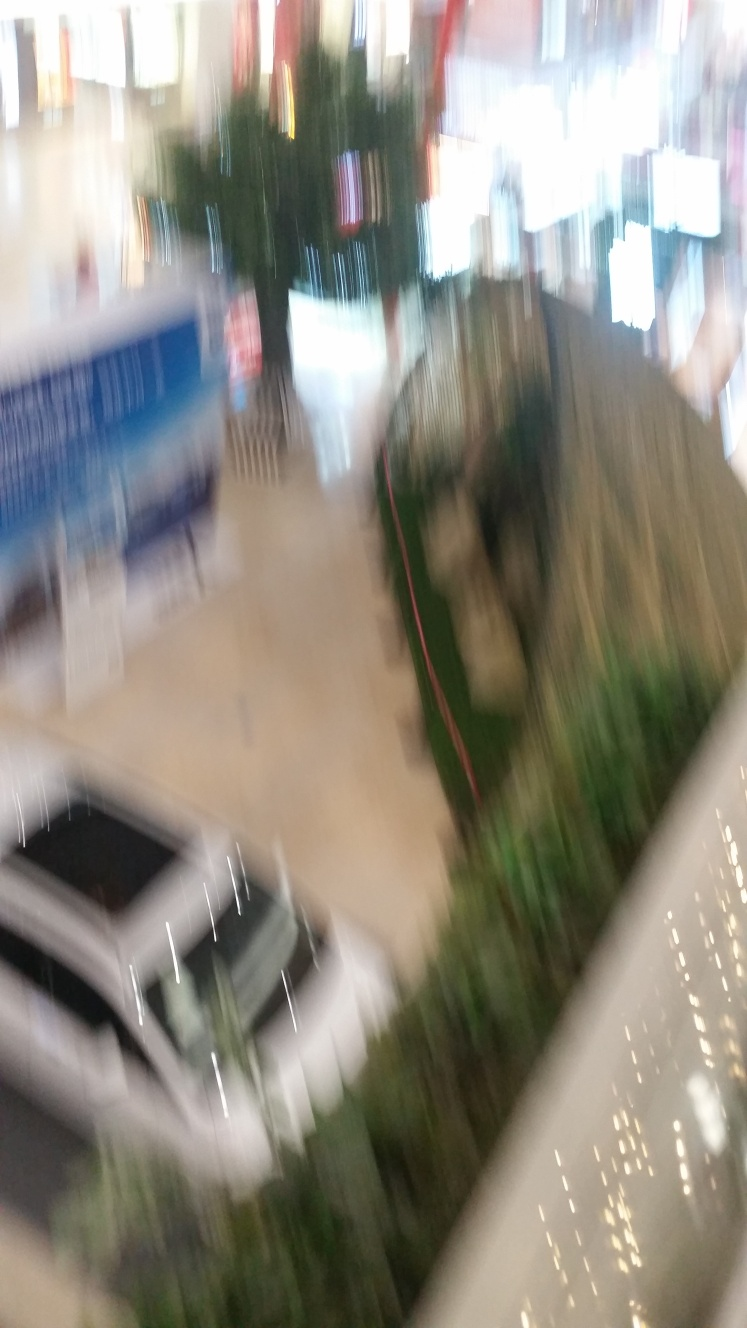Is the lighting sufficient in the image? Given the image's poor quality due to excessive motion blur, it is quite challenging to accurately assess the lighting conditions. We should consider obtaining a clearer image to evaluate the lighting properly. 